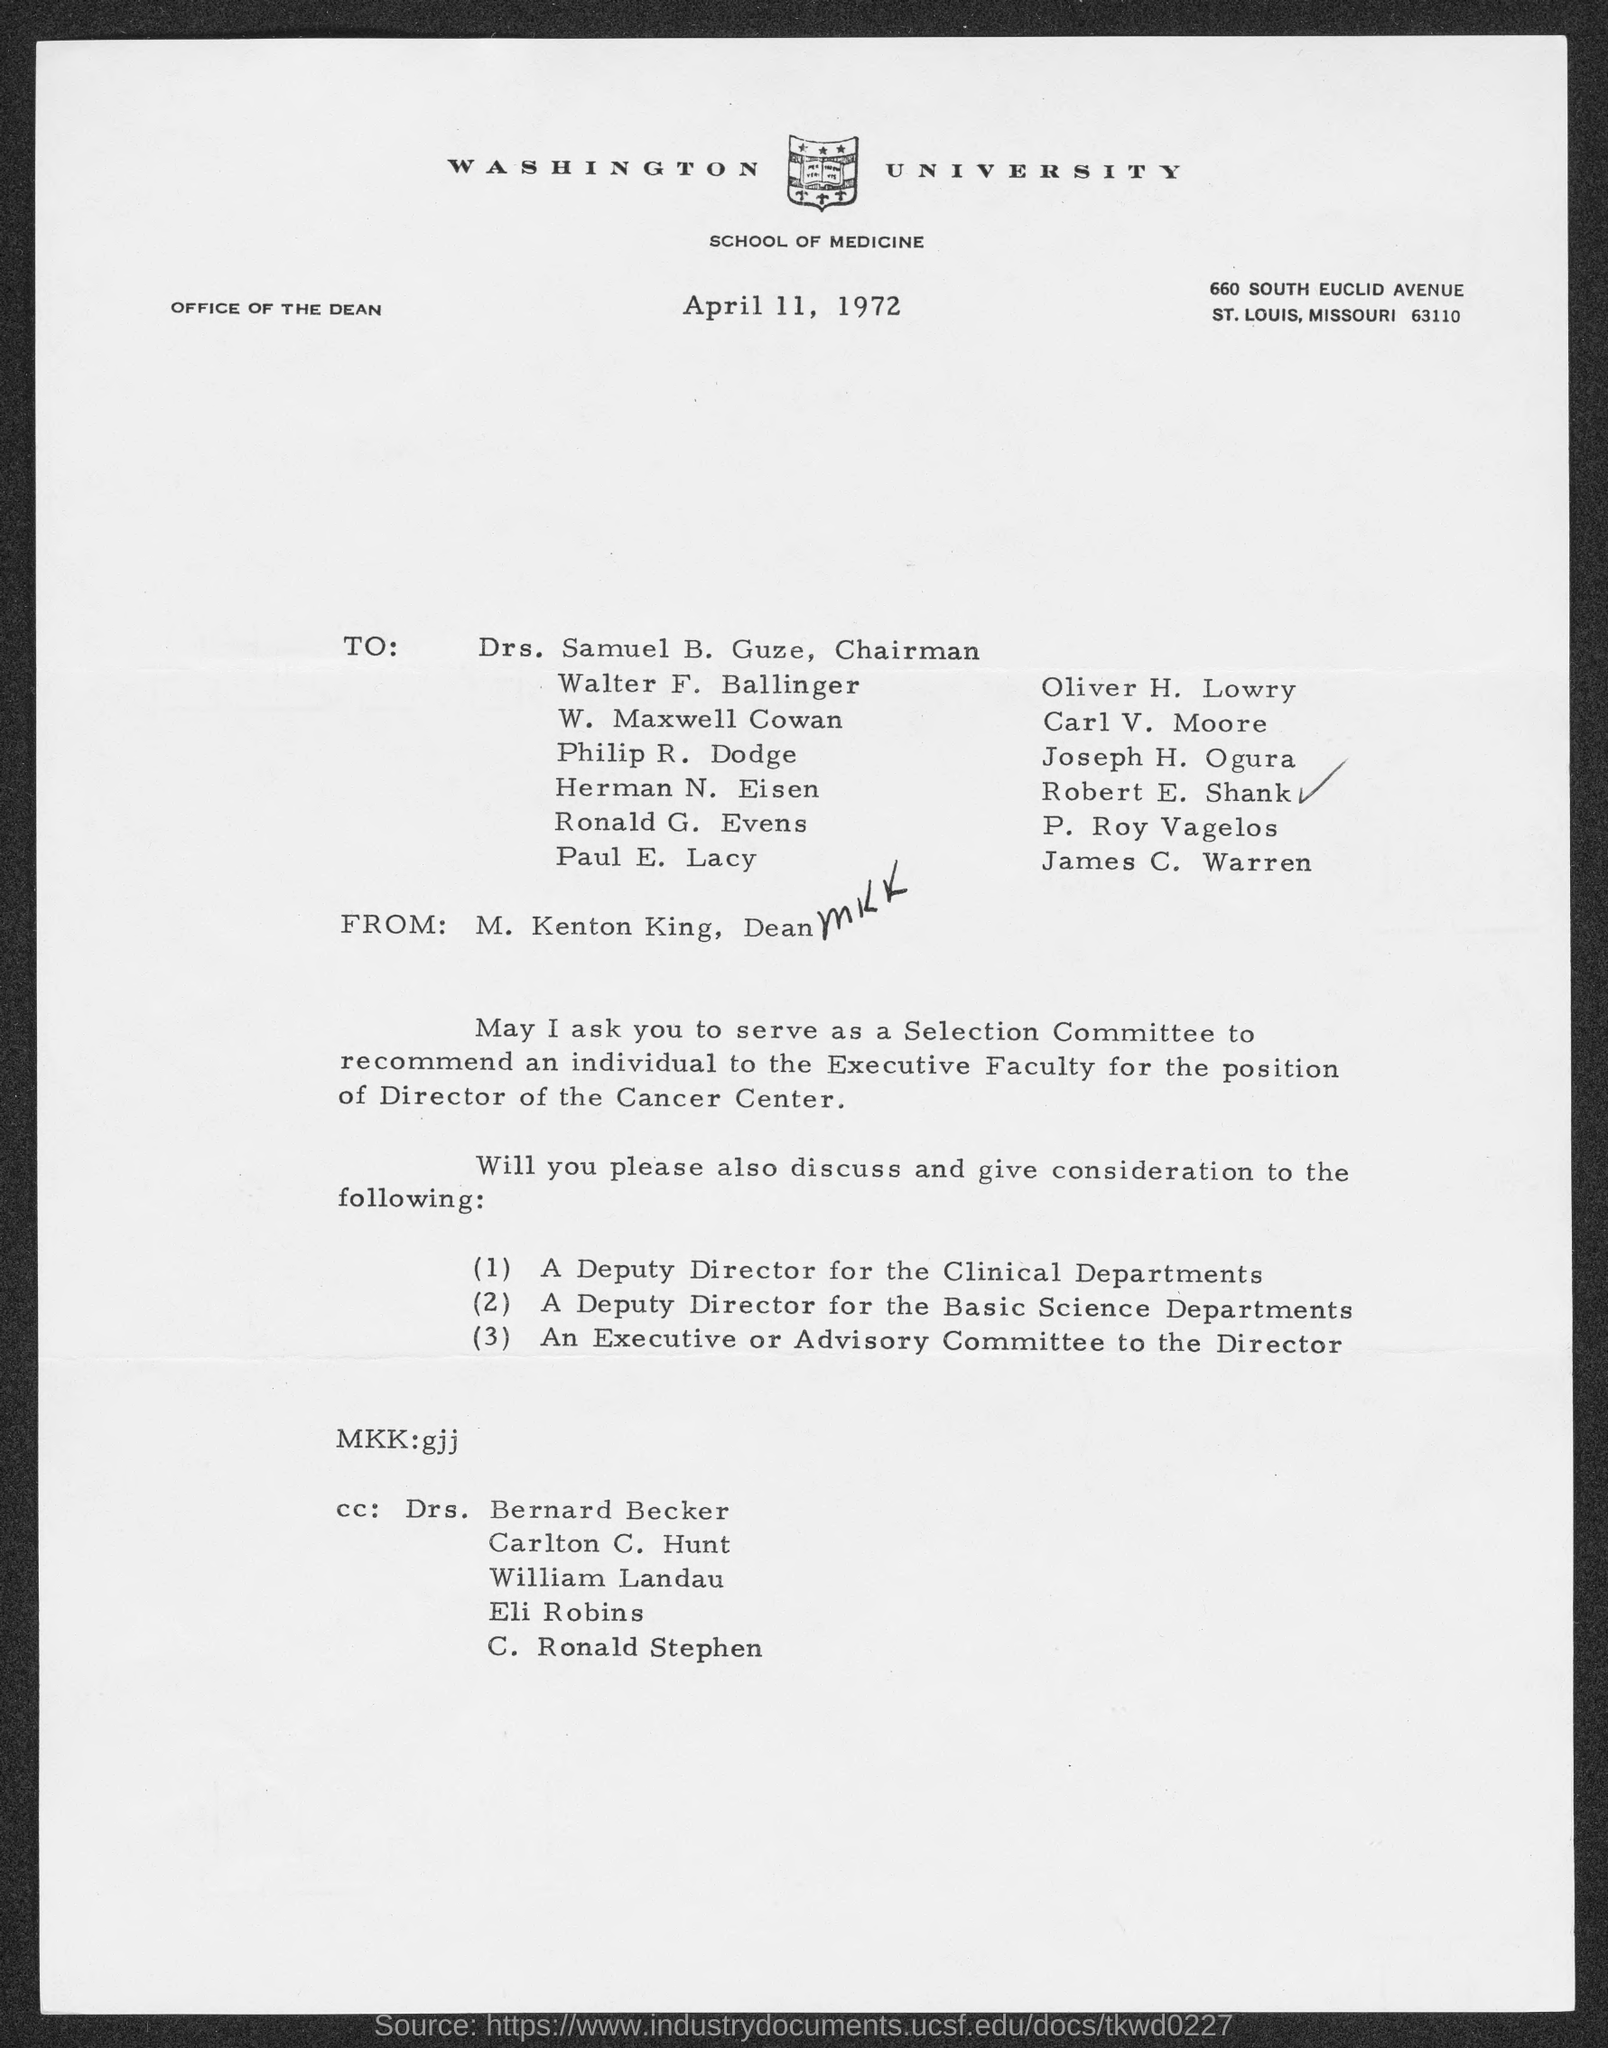Indicate a few pertinent items in this graphic. Washington University is mentioned in the letterhead. The date mentioned in this letter is April 11, 1972. 